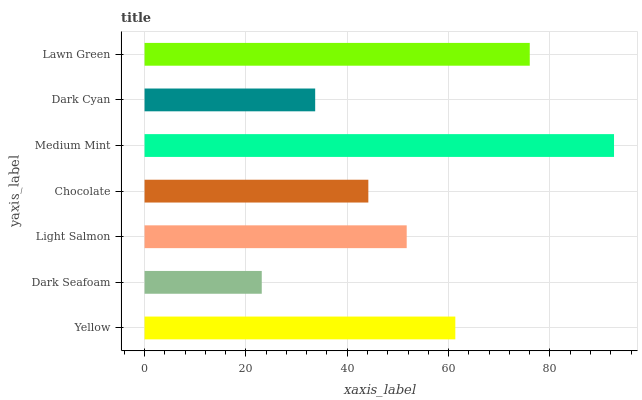Is Dark Seafoam the minimum?
Answer yes or no. Yes. Is Medium Mint the maximum?
Answer yes or no. Yes. Is Light Salmon the minimum?
Answer yes or no. No. Is Light Salmon the maximum?
Answer yes or no. No. Is Light Salmon greater than Dark Seafoam?
Answer yes or no. Yes. Is Dark Seafoam less than Light Salmon?
Answer yes or no. Yes. Is Dark Seafoam greater than Light Salmon?
Answer yes or no. No. Is Light Salmon less than Dark Seafoam?
Answer yes or no. No. Is Light Salmon the high median?
Answer yes or no. Yes. Is Light Salmon the low median?
Answer yes or no. Yes. Is Medium Mint the high median?
Answer yes or no. No. Is Dark Cyan the low median?
Answer yes or no. No. 